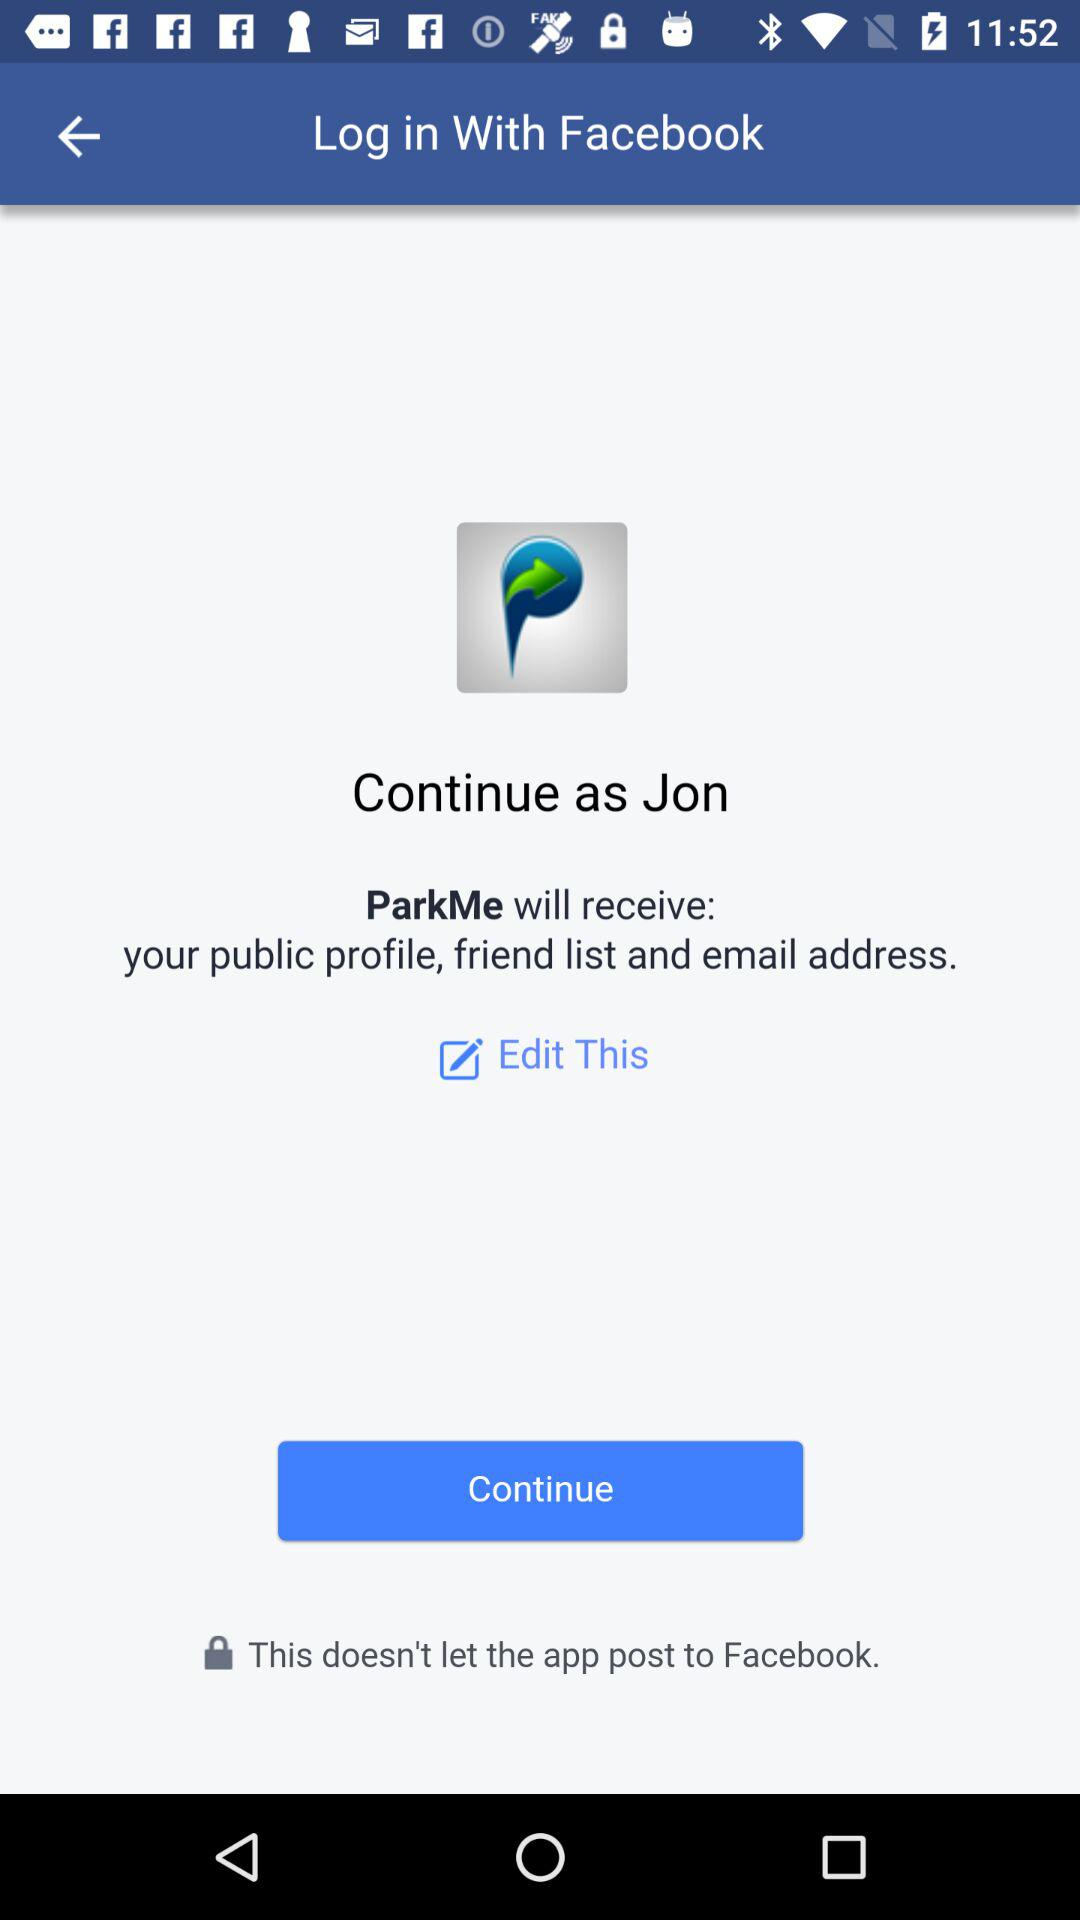What is the login name? The login name is Jon. 